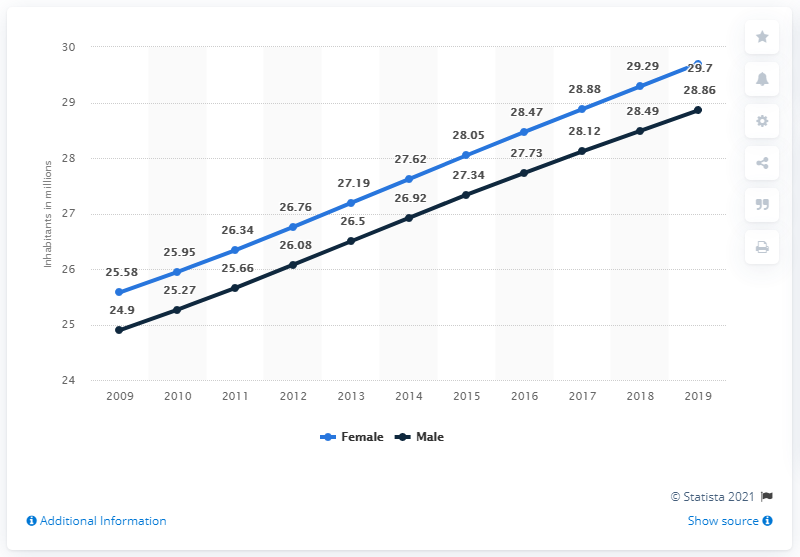Outline some significant characteristics in this image. In 2019, the female population of South Africa was 29.7 million. The male population of South Africa in 2019 was approximately 28.86 million. 